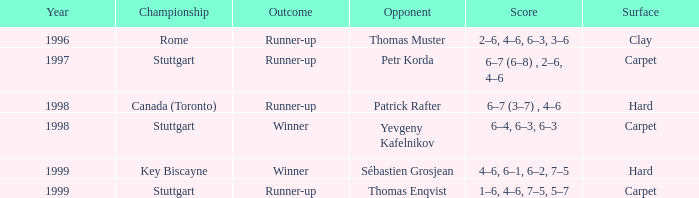How many years was the opponent petr korda? 1.0. 